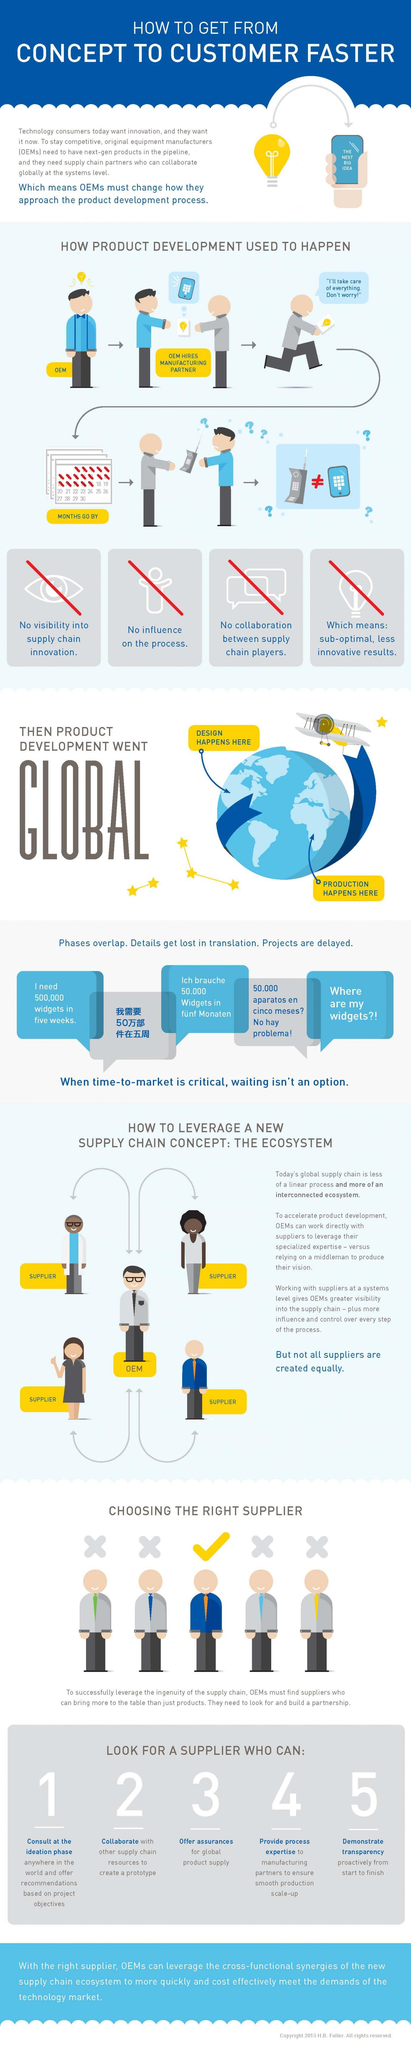How many points are given under the topic "look for a supplier who can:"
Answer the question with a short phrase. 5 How many cross mark symbols are there under the topic "choosing the right supplier"? 4 What is the second characteristic of a good supplier out of 5 given? collaborate with other supply chain resources to create a prototype What is the color of the bulb icon given below the heading - blue, yellow or white? yellow What is the third characteristic of a good supplier out of 5 given? offer assurances for global product supply What is the fourth characteristic of a good supplier out of 5 given? provide process expertise to manufacturing partners to ensure smooth production scale-up 